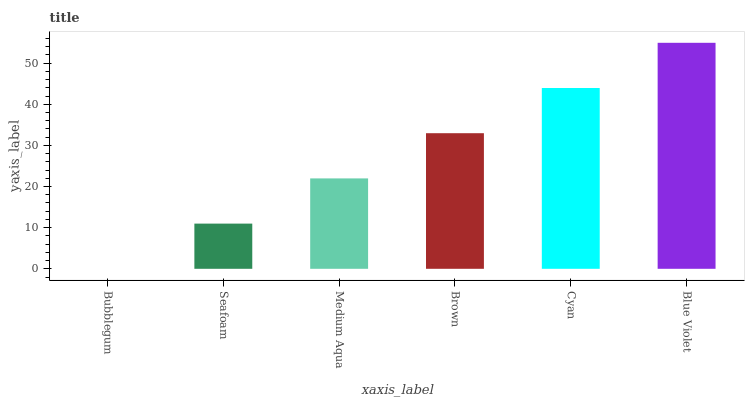Is Bubblegum the minimum?
Answer yes or no. Yes. Is Blue Violet the maximum?
Answer yes or no. Yes. Is Seafoam the minimum?
Answer yes or no. No. Is Seafoam the maximum?
Answer yes or no. No. Is Seafoam greater than Bubblegum?
Answer yes or no. Yes. Is Bubblegum less than Seafoam?
Answer yes or no. Yes. Is Bubblegum greater than Seafoam?
Answer yes or no. No. Is Seafoam less than Bubblegum?
Answer yes or no. No. Is Brown the high median?
Answer yes or no. Yes. Is Medium Aqua the low median?
Answer yes or no. Yes. Is Bubblegum the high median?
Answer yes or no. No. Is Bubblegum the low median?
Answer yes or no. No. 